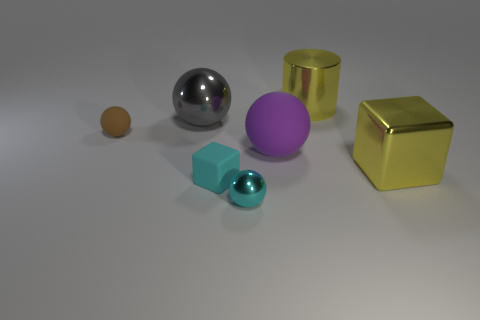Add 2 large green rubber blocks. How many objects exist? 9 Subtract all brown rubber balls. How many balls are left? 3 Subtract all balls. How many objects are left? 3 Subtract 3 spheres. How many spheres are left? 1 Subtract all green balls. Subtract all red cylinders. How many balls are left? 4 Subtract all yellow cylinders. How many red blocks are left? 0 Subtract all yellow metal cylinders. Subtract all large yellow metal cylinders. How many objects are left? 5 Add 6 gray metallic balls. How many gray metallic balls are left? 7 Add 7 brown matte blocks. How many brown matte blocks exist? 7 Subtract all cyan balls. How many balls are left? 3 